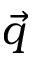Convert formula to latex. <formula><loc_0><loc_0><loc_500><loc_500>\vec { q }</formula> 